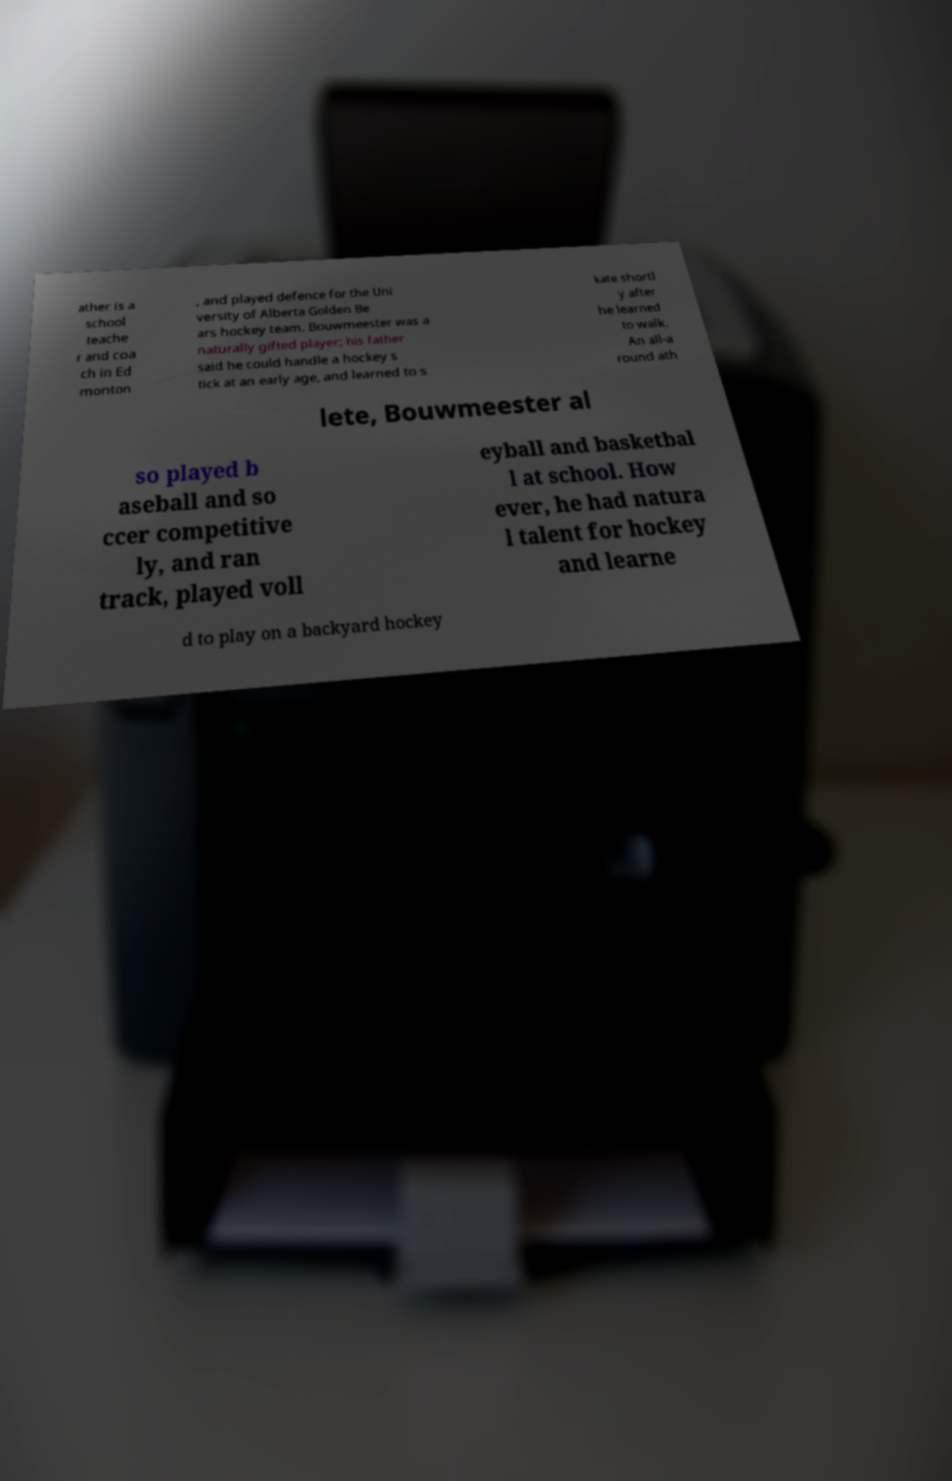For documentation purposes, I need the text within this image transcribed. Could you provide that? ather is a school teache r and coa ch in Ed monton , and played defence for the Uni versity of Alberta Golden Be ars hockey team. Bouwmeester was a naturally gifted player; his father said he could handle a hockey s tick at an early age, and learned to s kate shortl y after he learned to walk. An all-a round ath lete, Bouwmeester al so played b aseball and so ccer competitive ly, and ran track, played voll eyball and basketbal l at school. How ever, he had natura l talent for hockey and learne d to play on a backyard hockey 